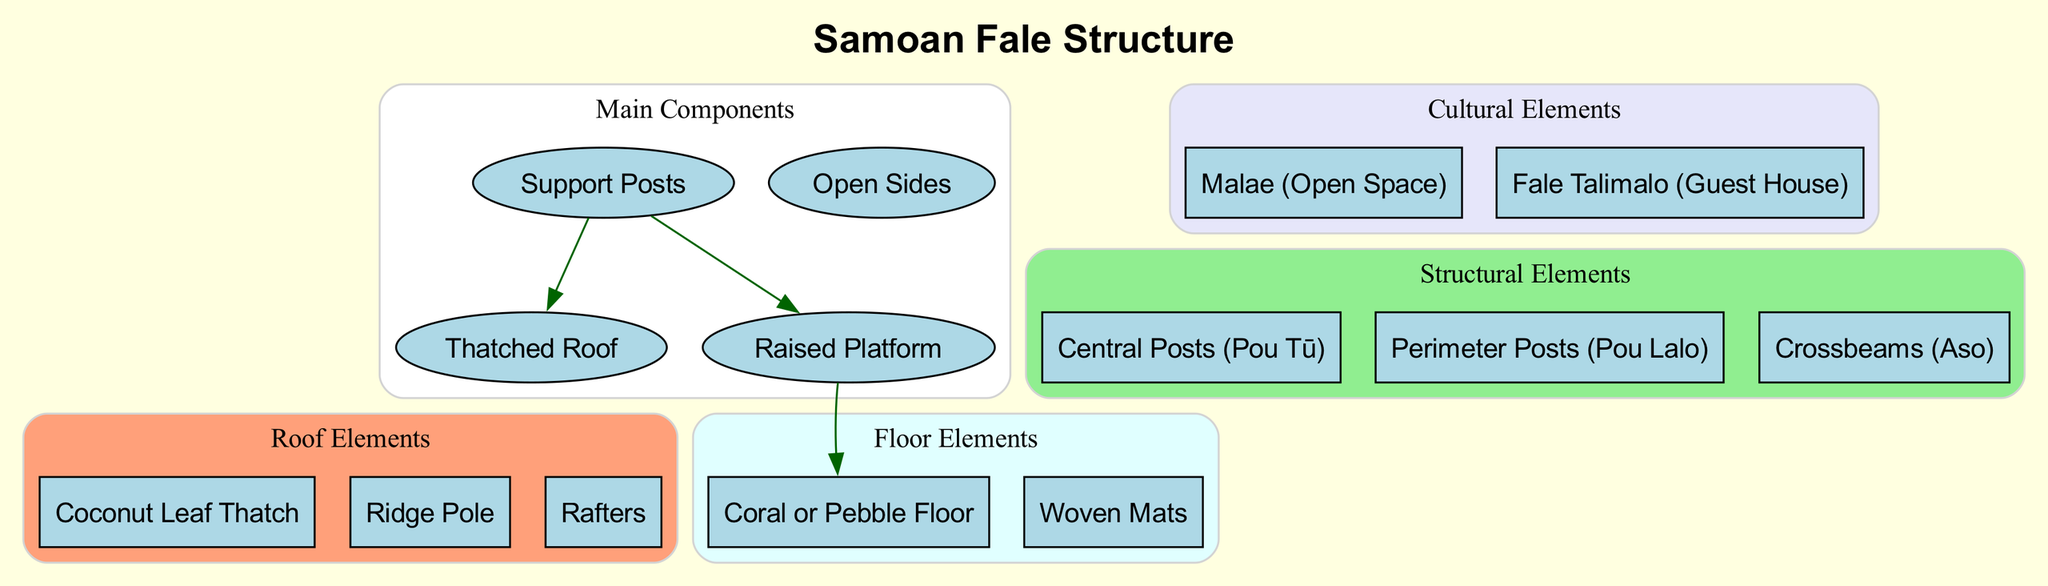What are the main components of a Samoan fale? The diagram lists four main components: Thatched Roof, Support Posts, Open Sides, and Raised Platform. By looking at the "Main Components" cluster, we can easily identify these elements listed within it.
Answer: Thatched Roof, Support Posts, Open Sides, Raised Platform How many roof elements are there? The diagram shows three roof elements: Coconut Leaf Thatch, Ridge Pole, and Rafters. We can count the elements detailed in the "Roof Elements" section to find the answer.
Answer: 3 Which element connects the Support Posts to the Thatched Roof? According to the diagram, there is a direct edge connecting Support Posts to the Thatched Roof, indicating a structural relationship between these two components. Thus, the answer is Thatched Roof.
Answer: Thatched Roof What type of floor is mentioned in the diagram? The diagram specifically notes that the floor is made of Coral or Pebble Floor and Woven Mats. We look in the "Floor Elements" section to confirm this detail. The answer is Coral or Pebble Floor.
Answer: Coral or Pebble Floor What is the purpose of the Malae mentioned in the diagram? The Malae is categorized under "Cultural Elements," which signifies its importance as an open space for gatherings and cultural events, representing a significant aspect of Samoan culture. The answer is cultural gathering space.
Answer: cultural gathering space Which structural element is also known as Pou Tū? The diagram indicates that the Central Posts are referred to as Pou Tū in Samoan. This information can be found in the "Structural Elements" section, where it is explicitly labeled.
Answer: Central Posts (Pou Tū) What connects the Raised Platform to the Coral or Pebble Floor? The diagram illustrates an edge connecting the Raised Platform to Coral or Pebble Floor, indicating the structural link between these two components. Thus, the answer is Coral or Pebble Floor.
Answer: Coral or Pebble Floor How are the Support Posts related to the Raised Platform? The diagram shows a direct edge linking Support Posts to the Raised Platform, indicating that the Support Posts help support or elevate the platform. This relationship is visible through the connection in the "Connections" section, where it is specifically labeled.
Answer: Raised Platform 